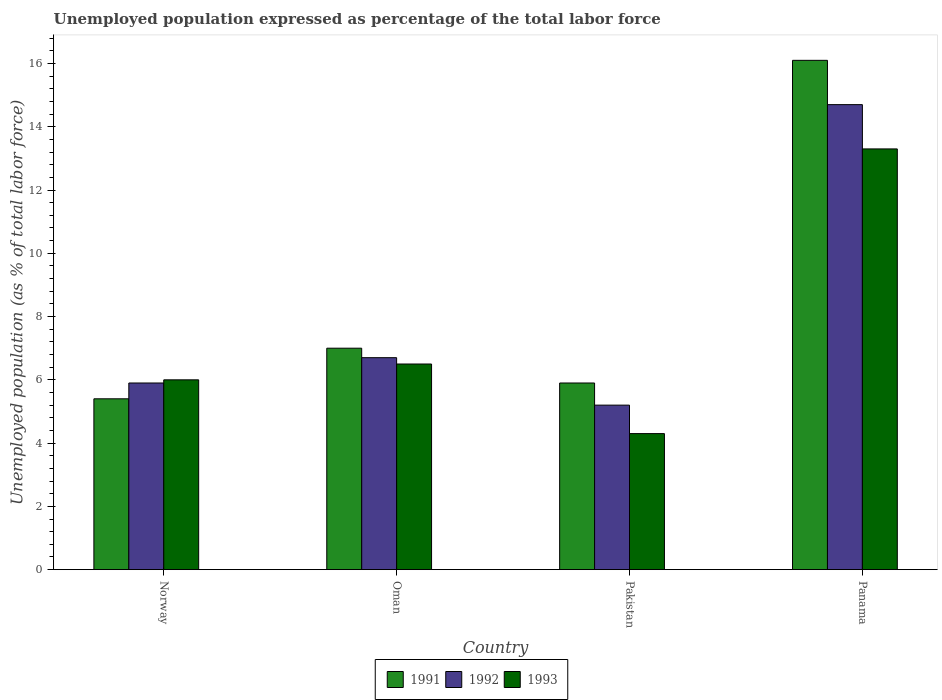How many different coloured bars are there?
Keep it short and to the point. 3. How many groups of bars are there?
Offer a terse response. 4. How many bars are there on the 1st tick from the right?
Your answer should be very brief. 3. What is the label of the 4th group of bars from the left?
Offer a terse response. Panama. What is the unemployment in in 1991 in Panama?
Provide a succinct answer. 16.1. Across all countries, what is the maximum unemployment in in 1992?
Your response must be concise. 14.7. Across all countries, what is the minimum unemployment in in 1991?
Keep it short and to the point. 5.4. In which country was the unemployment in in 1992 maximum?
Provide a succinct answer. Panama. In which country was the unemployment in in 1993 minimum?
Ensure brevity in your answer.  Pakistan. What is the total unemployment in in 1992 in the graph?
Give a very brief answer. 32.5. What is the difference between the unemployment in in 1993 in Oman and that in Pakistan?
Your answer should be very brief. 2.2. What is the difference between the unemployment in in 1991 in Oman and the unemployment in in 1993 in Pakistan?
Your response must be concise. 2.7. What is the average unemployment in in 1991 per country?
Keep it short and to the point. 8.6. What is the difference between the unemployment in of/in 1991 and unemployment in of/in 1993 in Norway?
Provide a succinct answer. -0.6. What is the ratio of the unemployment in in 1992 in Oman to that in Pakistan?
Your response must be concise. 1.29. Is the difference between the unemployment in in 1991 in Oman and Panama greater than the difference between the unemployment in in 1993 in Oman and Panama?
Provide a succinct answer. No. What is the difference between the highest and the second highest unemployment in in 1993?
Provide a short and direct response. 6.8. What is the difference between the highest and the lowest unemployment in in 1993?
Offer a very short reply. 9. Is the sum of the unemployment in in 1993 in Oman and Panama greater than the maximum unemployment in in 1991 across all countries?
Your answer should be very brief. Yes. What does the 3rd bar from the left in Norway represents?
Your response must be concise. 1993. What does the 1st bar from the right in Pakistan represents?
Keep it short and to the point. 1993. Are all the bars in the graph horizontal?
Provide a short and direct response. No. What is the difference between two consecutive major ticks on the Y-axis?
Your answer should be very brief. 2. How many legend labels are there?
Make the answer very short. 3. How are the legend labels stacked?
Make the answer very short. Horizontal. What is the title of the graph?
Provide a succinct answer. Unemployed population expressed as percentage of the total labor force. Does "2000" appear as one of the legend labels in the graph?
Offer a very short reply. No. What is the label or title of the Y-axis?
Your response must be concise. Unemployed population (as % of total labor force). What is the Unemployed population (as % of total labor force) of 1991 in Norway?
Provide a succinct answer. 5.4. What is the Unemployed population (as % of total labor force) in 1992 in Norway?
Make the answer very short. 5.9. What is the Unemployed population (as % of total labor force) in 1992 in Oman?
Keep it short and to the point. 6.7. What is the Unemployed population (as % of total labor force) in 1991 in Pakistan?
Keep it short and to the point. 5.9. What is the Unemployed population (as % of total labor force) of 1992 in Pakistan?
Your answer should be very brief. 5.2. What is the Unemployed population (as % of total labor force) in 1993 in Pakistan?
Keep it short and to the point. 4.3. What is the Unemployed population (as % of total labor force) in 1991 in Panama?
Provide a succinct answer. 16.1. What is the Unemployed population (as % of total labor force) in 1992 in Panama?
Your answer should be compact. 14.7. What is the Unemployed population (as % of total labor force) of 1993 in Panama?
Ensure brevity in your answer.  13.3. Across all countries, what is the maximum Unemployed population (as % of total labor force) in 1991?
Your response must be concise. 16.1. Across all countries, what is the maximum Unemployed population (as % of total labor force) of 1992?
Give a very brief answer. 14.7. Across all countries, what is the maximum Unemployed population (as % of total labor force) in 1993?
Offer a very short reply. 13.3. Across all countries, what is the minimum Unemployed population (as % of total labor force) in 1991?
Make the answer very short. 5.4. Across all countries, what is the minimum Unemployed population (as % of total labor force) of 1992?
Offer a very short reply. 5.2. Across all countries, what is the minimum Unemployed population (as % of total labor force) of 1993?
Make the answer very short. 4.3. What is the total Unemployed population (as % of total labor force) in 1991 in the graph?
Make the answer very short. 34.4. What is the total Unemployed population (as % of total labor force) in 1992 in the graph?
Provide a succinct answer. 32.5. What is the total Unemployed population (as % of total labor force) in 1993 in the graph?
Offer a terse response. 30.1. What is the difference between the Unemployed population (as % of total labor force) of 1993 in Norway and that in Oman?
Give a very brief answer. -0.5. What is the difference between the Unemployed population (as % of total labor force) of 1991 in Norway and that in Pakistan?
Ensure brevity in your answer.  -0.5. What is the difference between the Unemployed population (as % of total labor force) in 1992 in Norway and that in Pakistan?
Your answer should be very brief. 0.7. What is the difference between the Unemployed population (as % of total labor force) of 1993 in Norway and that in Pakistan?
Your answer should be compact. 1.7. What is the difference between the Unemployed population (as % of total labor force) in 1993 in Norway and that in Panama?
Your answer should be very brief. -7.3. What is the difference between the Unemployed population (as % of total labor force) in 1992 in Oman and that in Pakistan?
Make the answer very short. 1.5. What is the difference between the Unemployed population (as % of total labor force) in 1992 in Oman and that in Panama?
Keep it short and to the point. -8. What is the difference between the Unemployed population (as % of total labor force) of 1993 in Oman and that in Panama?
Provide a succinct answer. -6.8. What is the difference between the Unemployed population (as % of total labor force) in 1991 in Norway and the Unemployed population (as % of total labor force) in 1992 in Oman?
Offer a very short reply. -1.3. What is the difference between the Unemployed population (as % of total labor force) in 1991 in Norway and the Unemployed population (as % of total labor force) in 1993 in Oman?
Provide a short and direct response. -1.1. What is the difference between the Unemployed population (as % of total labor force) of 1992 in Norway and the Unemployed population (as % of total labor force) of 1993 in Oman?
Offer a terse response. -0.6. What is the difference between the Unemployed population (as % of total labor force) in 1991 in Norway and the Unemployed population (as % of total labor force) in 1992 in Pakistan?
Ensure brevity in your answer.  0.2. What is the difference between the Unemployed population (as % of total labor force) in 1992 in Norway and the Unemployed population (as % of total labor force) in 1993 in Panama?
Ensure brevity in your answer.  -7.4. What is the difference between the Unemployed population (as % of total labor force) of 1991 in Oman and the Unemployed population (as % of total labor force) of 1993 in Pakistan?
Give a very brief answer. 2.7. What is the difference between the Unemployed population (as % of total labor force) of 1992 in Oman and the Unemployed population (as % of total labor force) of 1993 in Pakistan?
Your answer should be compact. 2.4. What is the difference between the Unemployed population (as % of total labor force) in 1991 in Oman and the Unemployed population (as % of total labor force) in 1992 in Panama?
Your answer should be very brief. -7.7. What is the difference between the Unemployed population (as % of total labor force) in 1992 in Oman and the Unemployed population (as % of total labor force) in 1993 in Panama?
Offer a very short reply. -6.6. What is the difference between the Unemployed population (as % of total labor force) in 1991 in Pakistan and the Unemployed population (as % of total labor force) in 1992 in Panama?
Keep it short and to the point. -8.8. What is the difference between the Unemployed population (as % of total labor force) in 1991 in Pakistan and the Unemployed population (as % of total labor force) in 1993 in Panama?
Your answer should be very brief. -7.4. What is the difference between the Unemployed population (as % of total labor force) in 1992 in Pakistan and the Unemployed population (as % of total labor force) in 1993 in Panama?
Give a very brief answer. -8.1. What is the average Unemployed population (as % of total labor force) in 1992 per country?
Offer a very short reply. 8.12. What is the average Unemployed population (as % of total labor force) of 1993 per country?
Your response must be concise. 7.53. What is the difference between the Unemployed population (as % of total labor force) of 1991 and Unemployed population (as % of total labor force) of 1992 in Norway?
Your answer should be compact. -0.5. What is the difference between the Unemployed population (as % of total labor force) in 1992 and Unemployed population (as % of total labor force) in 1993 in Norway?
Ensure brevity in your answer.  -0.1. What is the difference between the Unemployed population (as % of total labor force) of 1991 and Unemployed population (as % of total labor force) of 1992 in Oman?
Ensure brevity in your answer.  0.3. What is the difference between the Unemployed population (as % of total labor force) of 1992 and Unemployed population (as % of total labor force) of 1993 in Oman?
Offer a very short reply. 0.2. What is the ratio of the Unemployed population (as % of total labor force) in 1991 in Norway to that in Oman?
Your answer should be very brief. 0.77. What is the ratio of the Unemployed population (as % of total labor force) in 1992 in Norway to that in Oman?
Ensure brevity in your answer.  0.88. What is the ratio of the Unemployed population (as % of total labor force) in 1993 in Norway to that in Oman?
Give a very brief answer. 0.92. What is the ratio of the Unemployed population (as % of total labor force) of 1991 in Norway to that in Pakistan?
Offer a terse response. 0.92. What is the ratio of the Unemployed population (as % of total labor force) in 1992 in Norway to that in Pakistan?
Offer a very short reply. 1.13. What is the ratio of the Unemployed population (as % of total labor force) in 1993 in Norway to that in Pakistan?
Provide a short and direct response. 1.4. What is the ratio of the Unemployed population (as % of total labor force) in 1991 in Norway to that in Panama?
Provide a succinct answer. 0.34. What is the ratio of the Unemployed population (as % of total labor force) of 1992 in Norway to that in Panama?
Your answer should be very brief. 0.4. What is the ratio of the Unemployed population (as % of total labor force) of 1993 in Norway to that in Panama?
Your answer should be compact. 0.45. What is the ratio of the Unemployed population (as % of total labor force) of 1991 in Oman to that in Pakistan?
Provide a succinct answer. 1.19. What is the ratio of the Unemployed population (as % of total labor force) of 1992 in Oman to that in Pakistan?
Make the answer very short. 1.29. What is the ratio of the Unemployed population (as % of total labor force) in 1993 in Oman to that in Pakistan?
Offer a very short reply. 1.51. What is the ratio of the Unemployed population (as % of total labor force) in 1991 in Oman to that in Panama?
Make the answer very short. 0.43. What is the ratio of the Unemployed population (as % of total labor force) in 1992 in Oman to that in Panama?
Your answer should be compact. 0.46. What is the ratio of the Unemployed population (as % of total labor force) of 1993 in Oman to that in Panama?
Give a very brief answer. 0.49. What is the ratio of the Unemployed population (as % of total labor force) of 1991 in Pakistan to that in Panama?
Offer a very short reply. 0.37. What is the ratio of the Unemployed population (as % of total labor force) in 1992 in Pakistan to that in Panama?
Provide a short and direct response. 0.35. What is the ratio of the Unemployed population (as % of total labor force) of 1993 in Pakistan to that in Panama?
Your answer should be very brief. 0.32. What is the difference between the highest and the second highest Unemployed population (as % of total labor force) of 1992?
Your answer should be very brief. 8. What is the difference between the highest and the lowest Unemployed population (as % of total labor force) of 1991?
Your answer should be very brief. 10.7. 